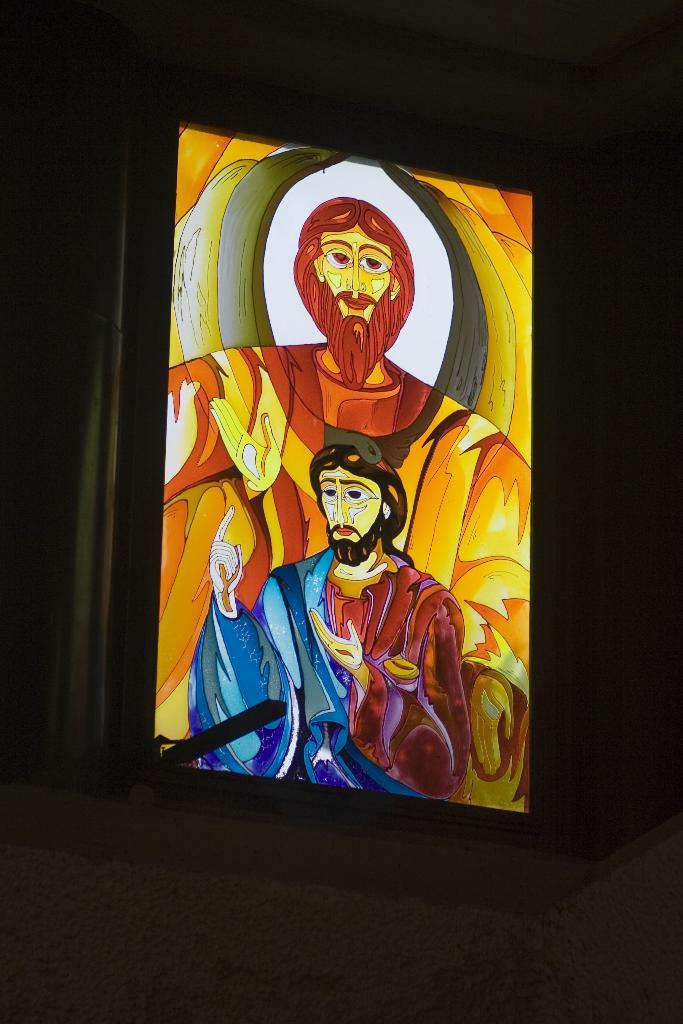What object is present in the image? There is a photo frame in the image. Can you describe the colors of the photo frame? The photo frame has multiple colors, including brown, yellow, blue, white, black, and maroon. What is the color of the background in the image? The background of the image is black. Are there any hands visible in the image, holding the photo frame? There are no hands visible in the image, as the focus is on the photo frame itself. 